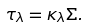<formula> <loc_0><loc_0><loc_500><loc_500>\tau _ { \lambda } = \kappa _ { \lambda } \Sigma .</formula> 